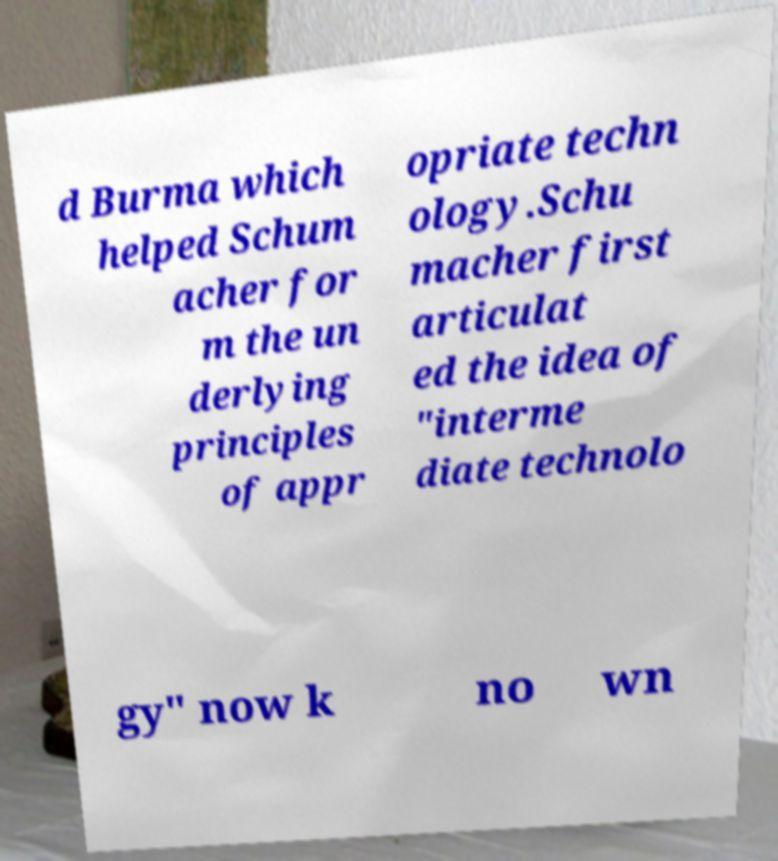I need the written content from this picture converted into text. Can you do that? d Burma which helped Schum acher for m the un derlying principles of appr opriate techn ology.Schu macher first articulat ed the idea of "interme diate technolo gy" now k no wn 